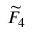Convert formula to latex. <formula><loc_0><loc_0><loc_500><loc_500>{ \widetilde { F } } _ { 4 }</formula> 